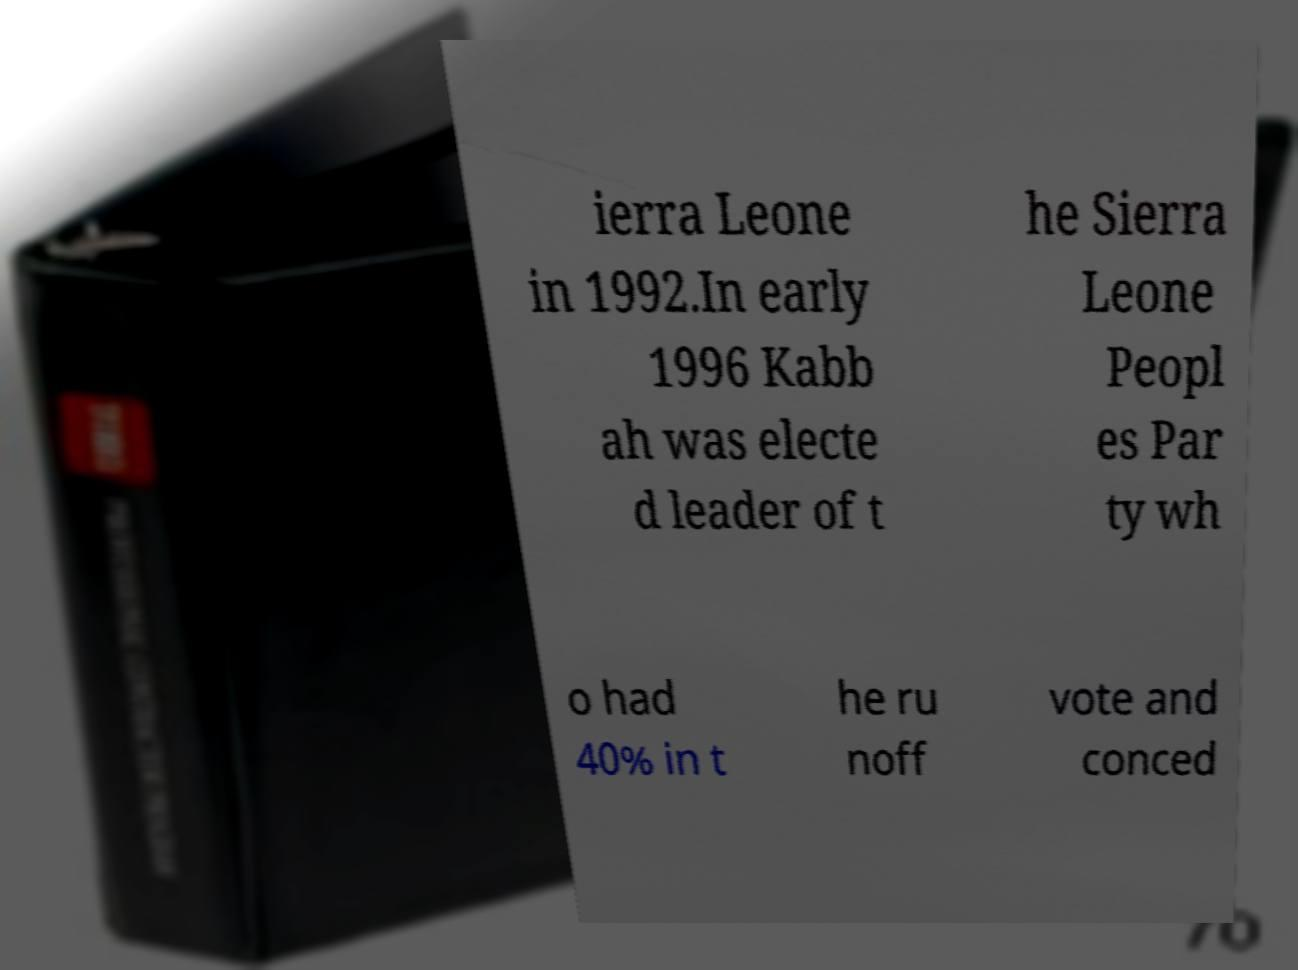Could you extract and type out the text from this image? ierra Leone in 1992.In early 1996 Kabb ah was electe d leader of t he Sierra Leone Peopl es Par ty wh o had 40% in t he ru noff vote and conced 